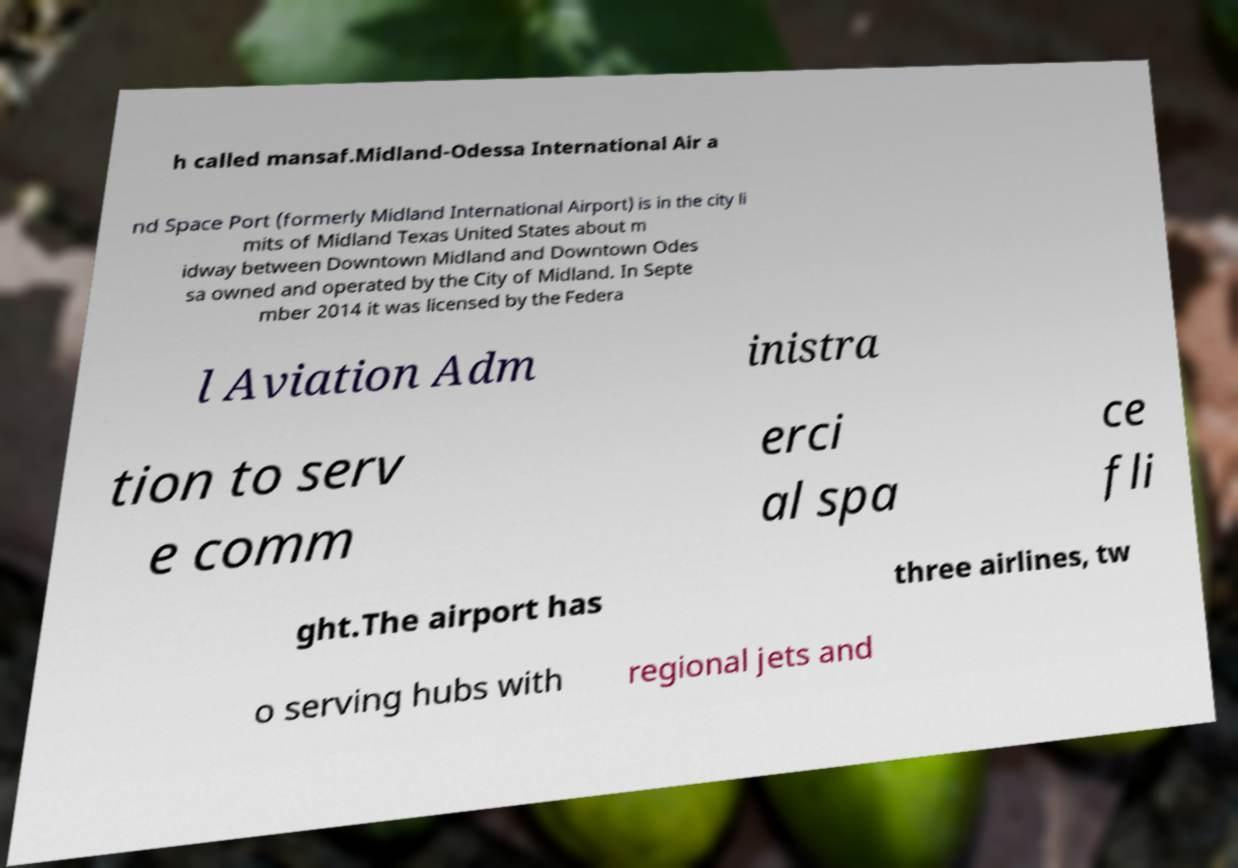What messages or text are displayed in this image? I need them in a readable, typed format. h called mansaf.Midland-Odessa International Air a nd Space Port (formerly Midland International Airport) is in the city li mits of Midland Texas United States about m idway between Downtown Midland and Downtown Odes sa owned and operated by the City of Midland. In Septe mber 2014 it was licensed by the Federa l Aviation Adm inistra tion to serv e comm erci al spa ce fli ght.The airport has three airlines, tw o serving hubs with regional jets and 